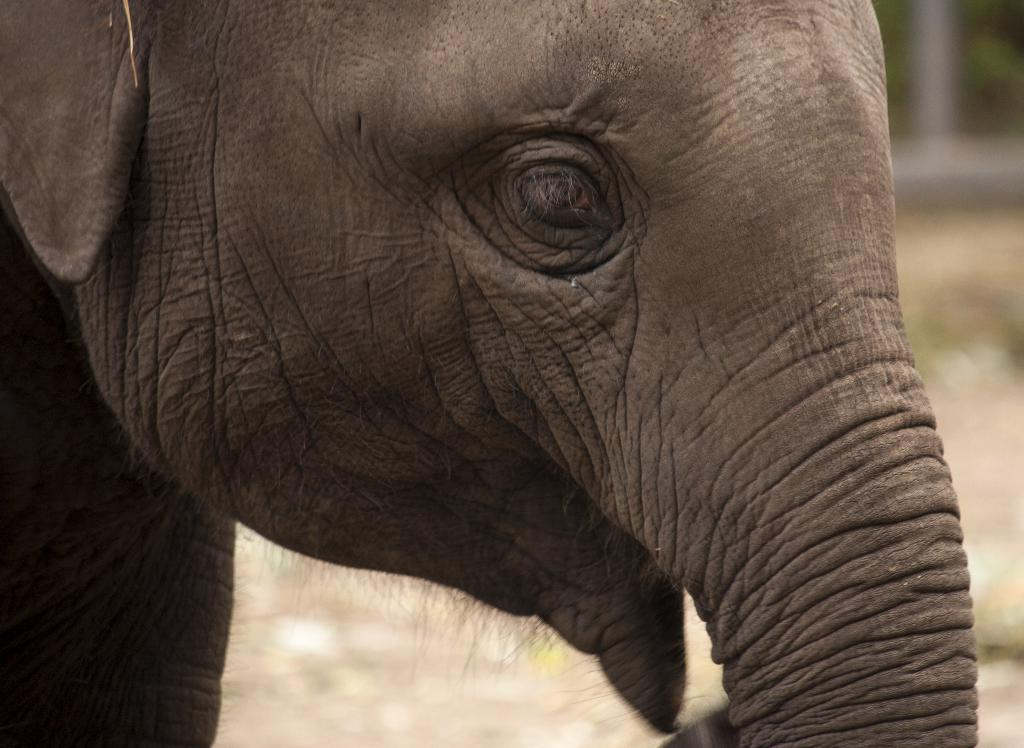What is the main subject of the picture? There is an elephant in the picture. Can you describe the background of the picture? The background of the picture is blurry. What type of fruit can be seen hanging from the elephant's trunk in the image? There is no fruit hanging from the elephant's trunk in the image. 